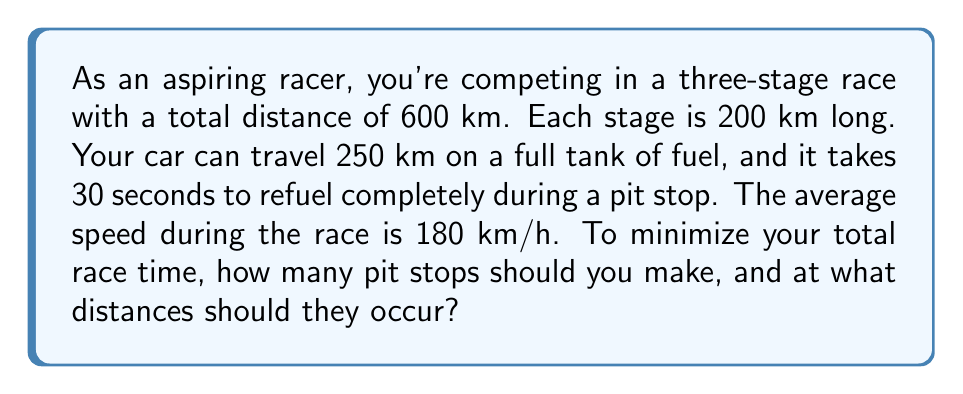Give your solution to this math problem. Let's approach this problem step-by-step:

1) First, we need to understand the constraints:
   - Total race distance: 600 km
   - Fuel capacity: 250 km
   - Pit stop time: 30 seconds = 0.5 minutes
   - Average speed: 180 km/h = 3 km/min

2) Without pit stops, the race would take:
   $$ \text{Time} = \frac{\text{Distance}}{\text{Speed}} = \frac{600 \text{ km}}{3 \text{ km/min}} = 200 \text{ minutes} $$

3) We need at least two pit stops to complete the race:
   $$ \text{Minimum pit stops} = \left\lceil\frac{600 \text{ km}}{250 \text{ km}}\right\rceil - 1 = 2 $$

4) Let's consider the optimal pit stop strategy:
   - Option 1: Two pit stops at 200 km and 400 km (stage ends)
   - Option 2: Two pit stops at 250 km and 500 km (full tank depletion)

5) For Option 1:
   - Time racing: 200 minutes
   - Time in pit stops: 2 * 0.5 = 1 minute
   - Total time: 201 minutes

6) For Option 2:
   - Time racing: 200 minutes
   - Time in pit stops: 2 * 0.5 = 1 minute
   - Total time: 201 minutes

7) Both options result in the same total time. However, Option 1 aligns with the stage ends, which might be more convenient and reduce the risk of running out of fuel.

Therefore, the optimal strategy is to make two pit stops, one at the end of each of the first two stages (200 km and 400 km).
Answer: Make 2 pit stops at 200 km and 400 km. 